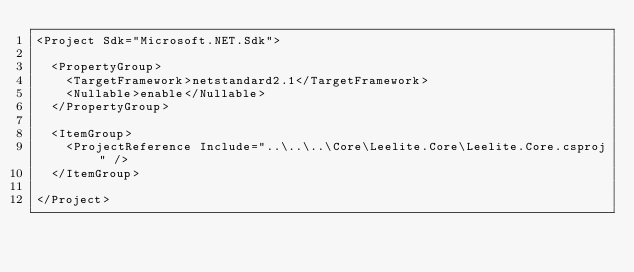Convert code to text. <code><loc_0><loc_0><loc_500><loc_500><_XML_><Project Sdk="Microsoft.NET.Sdk">

  <PropertyGroup>
    <TargetFramework>netstandard2.1</TargetFramework>
    <Nullable>enable</Nullable>
  </PropertyGroup>

  <ItemGroup>
    <ProjectReference Include="..\..\..\Core\Leelite.Core\Leelite.Core.csproj" />
  </ItemGroup>

</Project>
</code> 